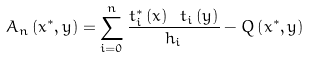<formula> <loc_0><loc_0><loc_500><loc_500>A _ { n } \left ( x ^ { \ast } , y \right ) = \sum _ { i = 0 } ^ { n } \frac { t _ { i } ^ { \ast } \left ( x \right ) \ t _ { i } \left ( y \right ) } { h _ { i } } - Q \left ( x ^ { \ast } , y \right )</formula> 